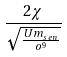Convert formula to latex. <formula><loc_0><loc_0><loc_500><loc_500>\frac { 2 \chi } { \sqrt { \frac { U m _ { s e n } } { o ^ { 9 } } } }</formula> 